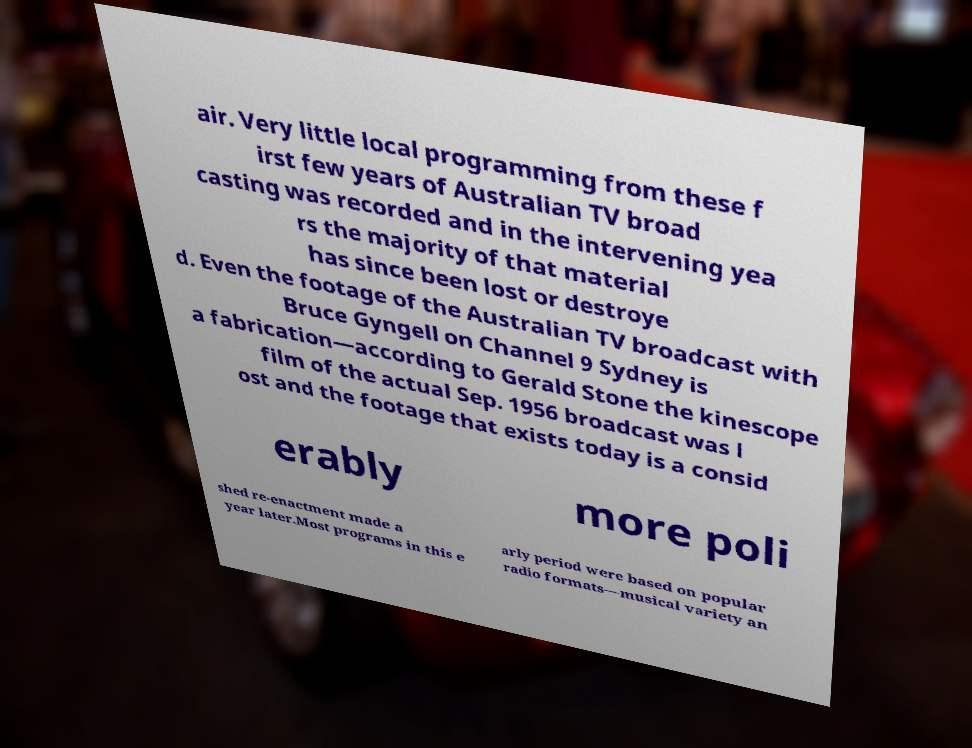Could you assist in decoding the text presented in this image and type it out clearly? air. Very little local programming from these f irst few years of Australian TV broad casting was recorded and in the intervening yea rs the majority of that material has since been lost or destroye d. Even the footage of the Australian TV broadcast with Bruce Gyngell on Channel 9 Sydney is a fabrication—according to Gerald Stone the kinescope film of the actual Sep. 1956 broadcast was l ost and the footage that exists today is a consid erably more poli shed re-enactment made a year later.Most programs in this e arly period were based on popular radio formats—musical variety an 